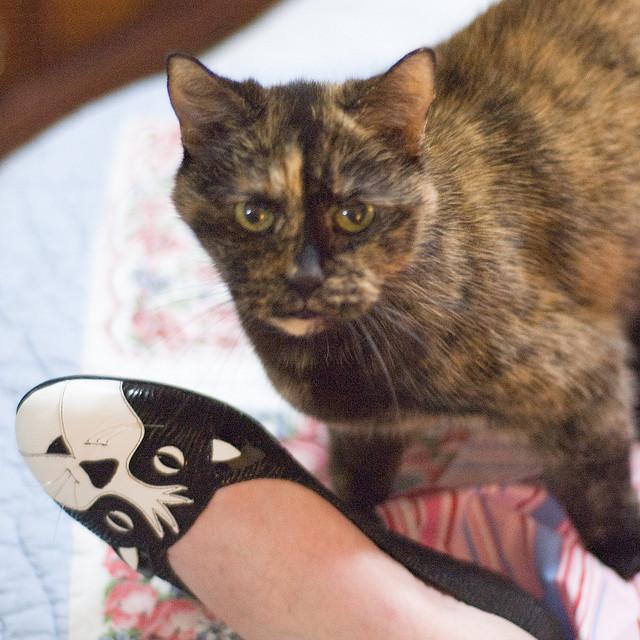What is one of the largest breeds of this animal? Please explain your reasoning. maine coon. This is a cat, and the maine coon is known as one of the largest domestic breeds. 